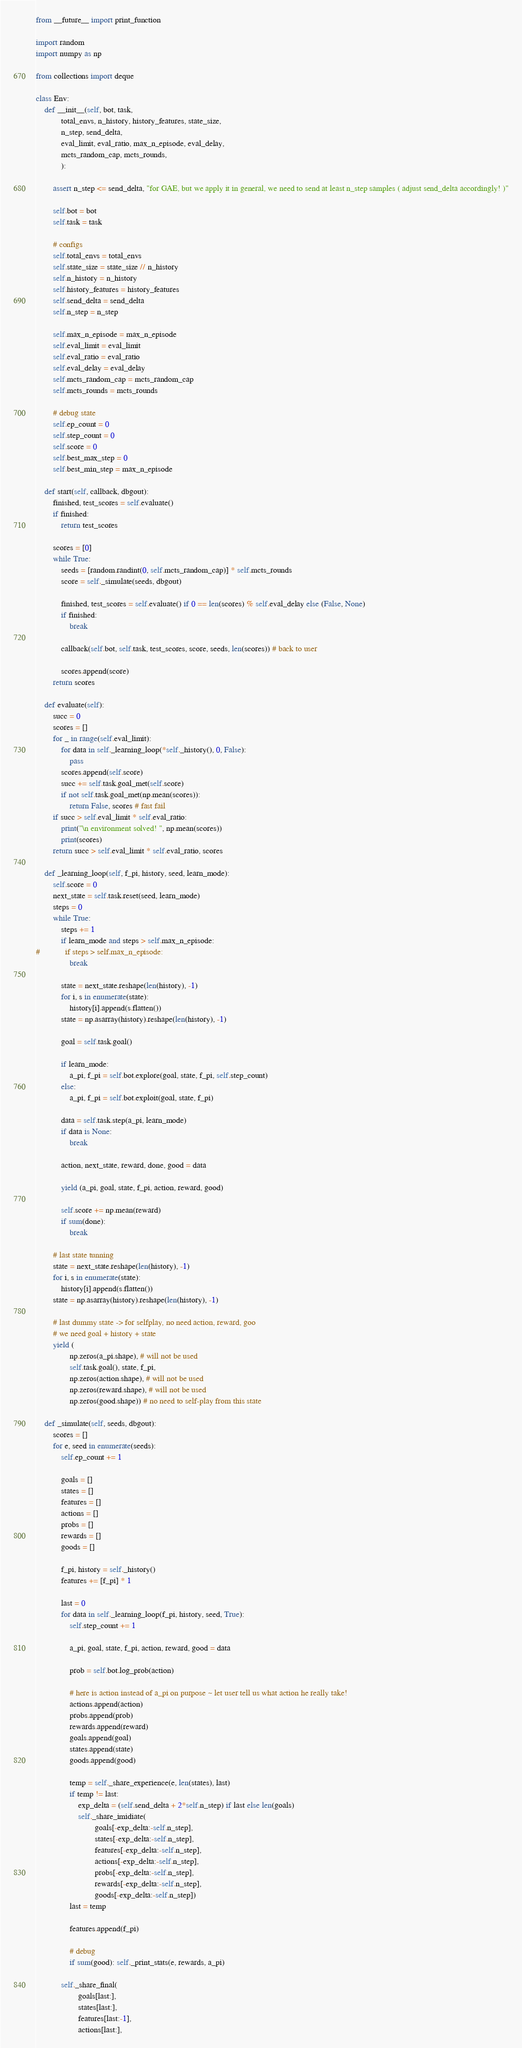Convert code to text. <code><loc_0><loc_0><loc_500><loc_500><_Python_>from __future__ import print_function

import random
import numpy as np

from collections import deque

class Env:
    def __init__(self, bot, task,
            total_envs, n_history, history_features, state_size,
            n_step, send_delta,
            eval_limit, eval_ratio, max_n_episode, eval_delay,
            mcts_random_cap, mcts_rounds,
            ):

        assert n_step <= send_delta, "for GAE, but we apply it in general, we need to send at least n_step samples ( adjust send_delta accordingly! )"

        self.bot = bot
        self.task = task

        # configs
        self.total_envs = total_envs
        self.state_size = state_size // n_history
        self.n_history = n_history
        self.history_features = history_features
        self.send_delta = send_delta
        self.n_step = n_step

        self.max_n_episode = max_n_episode
        self.eval_limit = eval_limit
        self.eval_ratio = eval_ratio
        self.eval_delay = eval_delay
        self.mcts_random_cap = mcts_random_cap
        self.mcts_rounds = mcts_rounds

        # debug state
        self.ep_count = 0
        self.step_count = 0
        self.score = 0
        self.best_max_step = 0
        self.best_min_step = max_n_episode

    def start(self, callback, dbgout):
        finished, test_scores = self.evaluate()
        if finished:
            return test_scores

        scores = [0]
        while True:
            seeds = [random.randint(0, self.mcts_random_cap)] * self.mcts_rounds
            score = self._simulate(seeds, dbgout)

            finished, test_scores = self.evaluate() if 0 == len(scores) % self.eval_delay else (False, None)
            if finished:
                break

            callback(self.bot, self.task, test_scores, score, seeds, len(scores)) # back to user

            scores.append(score)
        return scores

    def evaluate(self):
        succ = 0
        scores = []
        for _ in range(self.eval_limit):
            for data in self._learning_loop(*self._history(), 0, False):
                pass
            scores.append(self.score)
            succ += self.task.goal_met(self.score)
            if not self.task.goal_met(np.mean(scores)):
                return False, scores # fast fail
        if succ > self.eval_limit * self.eval_ratio:
            print("\n environment solved! ", np.mean(scores))
            print(scores)
        return succ > self.eval_limit * self.eval_ratio, scores

    def _learning_loop(self, f_pi, history, seed, learn_mode):
        self.score = 0
        next_state = self.task.reset(seed, learn_mode)
        steps = 0
        while True:
            steps += 1
            if learn_mode and steps > self.max_n_episode:
#            if steps > self.max_n_episode:
                break

            state = next_state.reshape(len(history), -1)
            for i, s in enumerate(state):
                history[i].append(s.flatten())
            state = np.asarray(history).reshape(len(history), -1)

            goal = self.task.goal()

            if learn_mode:
                a_pi, f_pi = self.bot.explore(goal, state, f_pi, self.step_count)
            else:
                a_pi, f_pi = self.bot.exploit(goal, state, f_pi)

            data = self.task.step(a_pi, learn_mode)
            if data is None:
                break

            action, next_state, reward, done, good = data

            yield (a_pi, goal, state, f_pi, action, reward, good)

            self.score += np.mean(reward)
            if sum(done):
                break

        # last state tunning
        state = next_state.reshape(len(history), -1)
        for i, s in enumerate(state):
            history[i].append(s.flatten())
        state = np.asarray(history).reshape(len(history), -1)

        # last dummy state -> for selfplay, no need action, reward, goo
        # we need goal + history + state
        yield (
                np.zeros(a_pi.shape), # will not be used
                self.task.goal(), state, f_pi,
                np.zeros(action.shape), # will not be used
                np.zeros(reward.shape), # will not be used
                np.zeros(good.shape)) # no need to self-play from this state

    def _simulate(self, seeds, dbgout):
        scores = []
        for e, seed in enumerate(seeds):
            self.ep_count += 1

            goals = []
            states = []
            features = []
            actions = []
            probs = []
            rewards = []
            goods = []

            f_pi, history = self._history()
            features += [f_pi] * 1

            last = 0
            for data in self._learning_loop(f_pi, history, seed, True):
                self.step_count += 1

                a_pi, goal, state, f_pi, action, reward, good = data

                prob = self.bot.log_prob(action)

                # here is action instead of a_pi on purpose ~ let user tell us what action he really take!
                actions.append(action)
                probs.append(prob)
                rewards.append(reward)
                goals.append(goal)
                states.append(state)
                goods.append(good)

                temp = self._share_experience(e, len(states), last)
                if temp != last:
                    exp_delta = (self.send_delta + 2*self.n_step) if last else len(goals)
                    self._share_imidiate(
                            goals[-exp_delta:-self.n_step],
                            states[-exp_delta:-self.n_step],
                            features[-exp_delta:-self.n_step],
                            actions[-exp_delta:-self.n_step],
                            probs[-exp_delta:-self.n_step],
                            rewards[-exp_delta:-self.n_step],
                            goods[-exp_delta:-self.n_step])
                last = temp

                features.append(f_pi)

                # debug
                if sum(good): self._print_stats(e, rewards, a_pi)

            self._share_final(
                    goals[last:],
                    states[last:],
                    features[last:-1],
                    actions[last:],</code> 